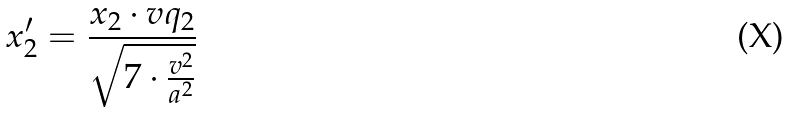<formula> <loc_0><loc_0><loc_500><loc_500>x _ { 2 } ^ { \prime } = \frac { x _ { 2 } \cdot v q _ { 2 } } { \sqrt { 7 \cdot \frac { v ^ { 2 } } { a ^ { 2 } } } }</formula> 